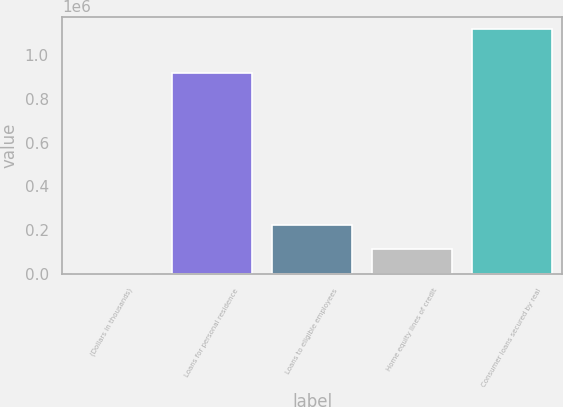Convert chart to OTSL. <chart><loc_0><loc_0><loc_500><loc_500><bar_chart><fcel>(Dollars in thousands)<fcel>Loans for personal residence<fcel>Loans to eligible employees<fcel>Home equity lines of credit<fcel>Consumer loans secured by real<nl><fcel>2014<fcel>918629<fcel>225234<fcel>113624<fcel>1.11812e+06<nl></chart> 